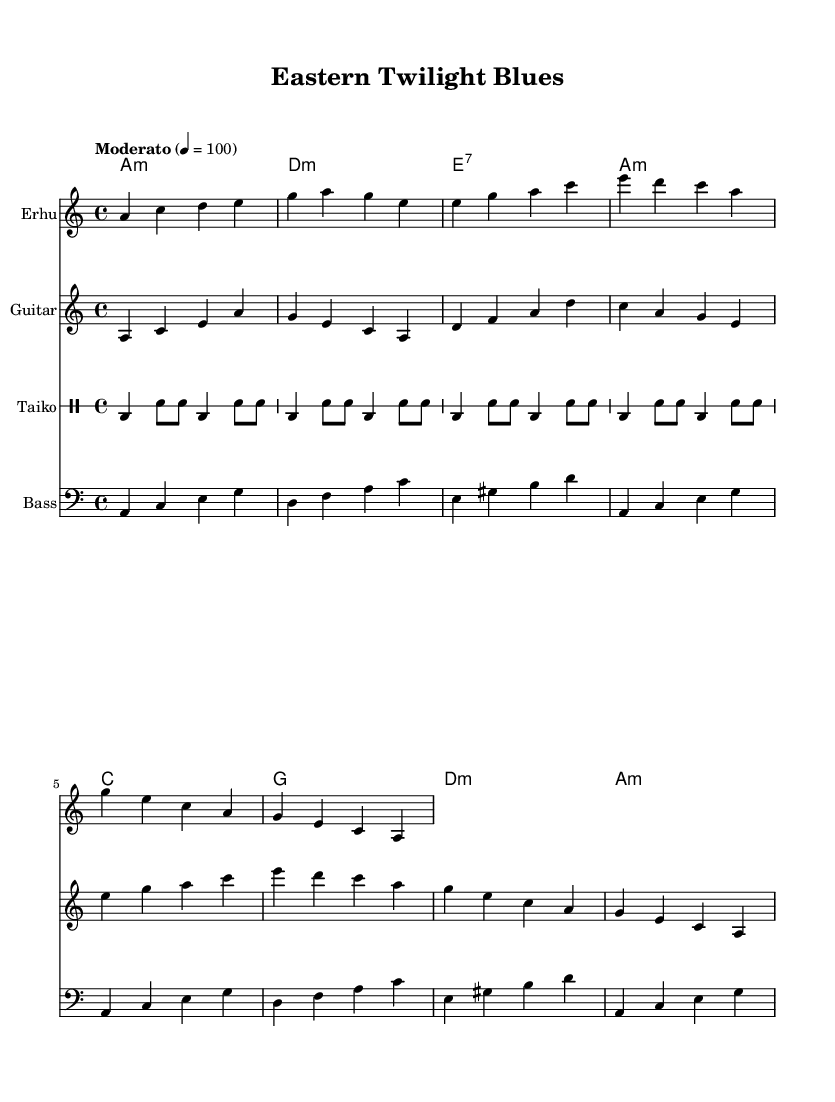What is the key signature of this music? The key signature indicates the music is in A minor, which has no sharps or flats.
Answer: A minor What is the time signature of the piece? The time signature is represented as 4/4, meaning there are four beats in each measure and the quarter note gets one beat.
Answer: 4/4 What is the tempo marking given in the music? The tempo marking states "Moderato," which indicates a moderate speed, typically around 100 beats per minute.
Answer: Moderato Identify the instrument that plays the intro in the music. The intro is played by the Erhu, as indicated by the instrument name in the staff notation.
Answer: Erhu How many measures are in the guitar verse? By analyzing the guitar part, it can be observed that there are two measures presented for the guitar verse section.
Answer: 2 measures Which Asian traditional instrument is featured prominently in the fusion? The prominent traditional instrument in this fusion piece is the Erhu, known for its expressive sound and unique timbre.
Answer: Erhu What is the overall structure of the piece based on the sections provided? The piece follows a simple structure with an intro, verse, and chorus, showcasing elements typical of a blues style that incorporates both Western and Asian influences.
Answer: Intro, Verse, Chorus 